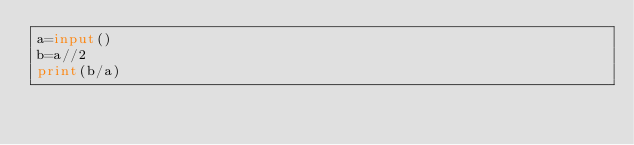Convert code to text. <code><loc_0><loc_0><loc_500><loc_500><_Python_>a=input()
b=a//2
print(b/a)</code> 